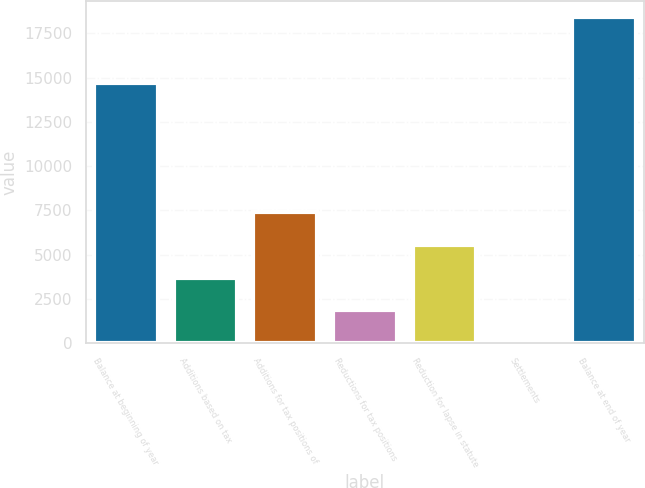Convert chart to OTSL. <chart><loc_0><loc_0><loc_500><loc_500><bar_chart><fcel>Balance at beginning of year<fcel>Additions based on tax<fcel>Additions for tax positions of<fcel>Reductions for tax positions<fcel>Reduction for lapse in statute<fcel>Settlements<fcel>Balance at end of year<nl><fcel>14697<fcel>3707.2<fcel>7387.4<fcel>1867.1<fcel>5547.3<fcel>27<fcel>18428<nl></chart> 